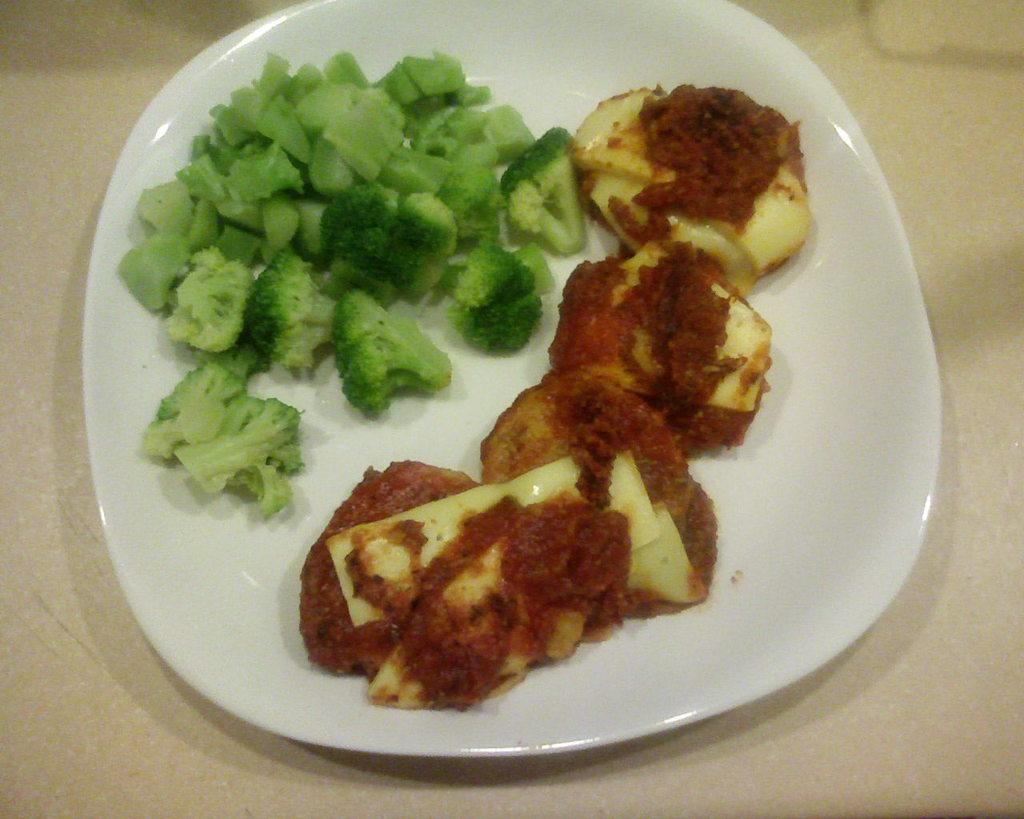What is present on the plate in the image? There are food items on a plate in the image. What is causing the alarm to go off in the image? There is no alarm present in the image, as it only features food items on a plate. 